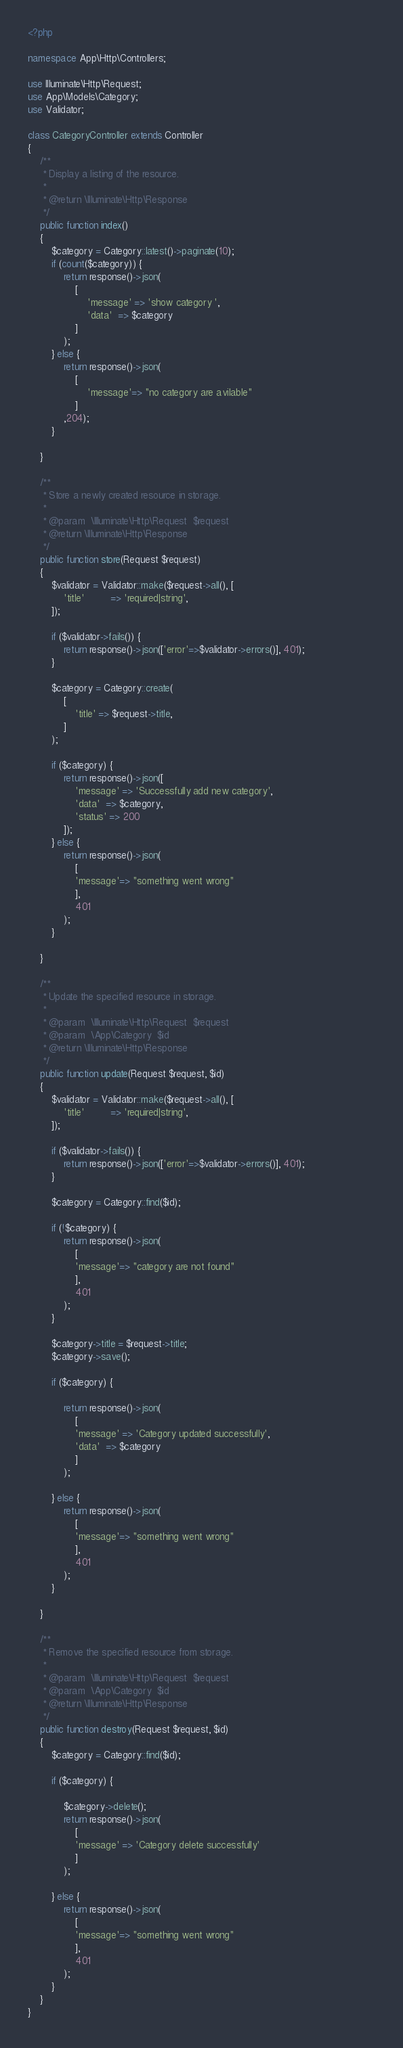Convert code to text. <code><loc_0><loc_0><loc_500><loc_500><_PHP_><?php

namespace App\Http\Controllers;

use Illuminate\Http\Request;
use App\Models\Category;
use Validator;

class CategoryController extends Controller
{
    /**
     * Display a listing of the resource.
     *
     * @return \Illuminate\Http\Response
     */
    public function index()
    {
        $category = Category::latest()->paginate(10);
        if (count($category)) {
            return response()->json(
                [
                    'message' => 'show category ',
                    'data'  => $category
                ]
            );
        } else {
            return response()->json(
                [
                    'message'=> "no category are avilable"
                ]
            ,204);   
        }
        
    }

    /**
     * Store a newly created resource in storage.
     *
     * @param  \Illuminate\Http\Request  $request
     * @return \Illuminate\Http\Response
     */
    public function store(Request $request)
    {
        $validator = Validator::make($request->all(), [
            'title'         => 'required|string',
        ]);
  
        if ($validator->fails()) {             
            return response()->json(['error'=>$validator->errors()], 401);                        
        }
    
        $category = Category::create(
            [
                'title' => $request->title,
            ]
        );
     
        if ($category) {
            return response()->json([
                'message' => 'Successfully add new category',
                'data'  => $category,
                'status' => 200
            ]);
        } else {
            return response()->json(
                [
                'message'=> "something went wrong"
                ], 
                401
            );   
        }
        
    }

    /**
     * Update the specified resource in storage.
     *
     * @param  \Illuminate\Http\Request  $request
     * @param  \App\Category  $id
     * @return \Illuminate\Http\Response
     */
    public function update(Request $request, $id)
    {
        $validator = Validator::make($request->all(), [
            'title'         => 'required|string',
        ]);
  
        if ($validator->fails()) {             
            return response()->json(['error'=>$validator->errors()], 401);                        
        }
  
        $category = Category::find($id);

        if (!$category) {
            return response()->json(
                [
                'message'=> "category are not found"
                ], 
                401
            );
        }         
                 
        $category->title = $request->title;
        $category->save();
         
        if ($category) {
            
            return response()->json(
                [
                'message' => 'Category updated successfully',
                'data'  => $category
                ]
            );

        } else {
            return response()->json(
                [
                'message'=> "something went wrong"
                ], 
                401
            );    
        }
        
    }

    /**
     * Remove the specified resource from storage.
     *
     * @param  \Illuminate\Http\Request  $request
     * @param  \App\Category  $id
     * @return \Illuminate\Http\Response
     */
    public function destroy(Request $request, $id)
    {
        $category = Category::find($id);           
        
        if ($category) {

            $category->delete();             
            return response()->json(
                [
                'message' => 'Category delete successfully'
                ]
            );

        } else {
            return response()->json(
                [
                'message'=> "something went wrong"
                ], 
                401
            );    
        }
    }
}
</code> 